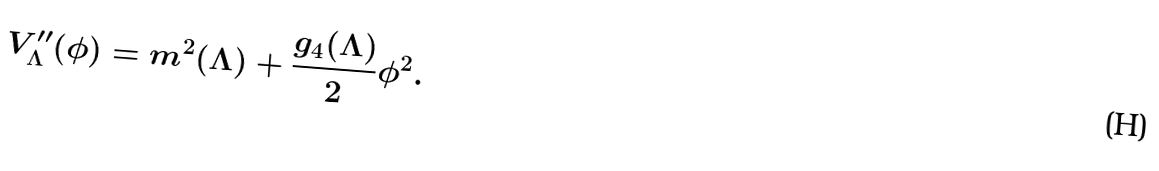Convert formula to latex. <formula><loc_0><loc_0><loc_500><loc_500>V _ { \Lambda } ^ { \prime \prime } ( \phi ) = m ^ { 2 } ( \Lambda ) + \frac { g _ { 4 } ( \Lambda ) } { 2 } \phi ^ { 2 } .</formula> 